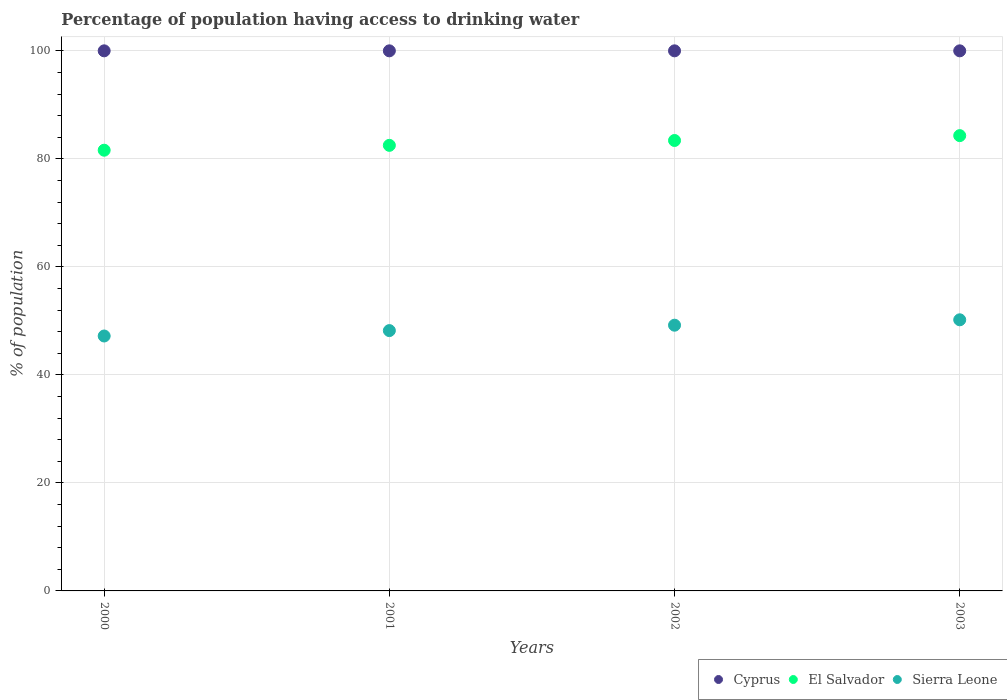What is the percentage of population having access to drinking water in Cyprus in 2001?
Your response must be concise. 100. Across all years, what is the maximum percentage of population having access to drinking water in El Salvador?
Ensure brevity in your answer.  84.3. Across all years, what is the minimum percentage of population having access to drinking water in El Salvador?
Your answer should be compact. 81.6. In which year was the percentage of population having access to drinking water in Sierra Leone minimum?
Give a very brief answer. 2000. What is the total percentage of population having access to drinking water in El Salvador in the graph?
Your answer should be compact. 331.8. What is the difference between the percentage of population having access to drinking water in Sierra Leone in 2002 and that in 2003?
Your answer should be very brief. -1. What is the difference between the percentage of population having access to drinking water in El Salvador in 2002 and the percentage of population having access to drinking water in Sierra Leone in 2003?
Make the answer very short. 33.2. In the year 2000, what is the difference between the percentage of population having access to drinking water in El Salvador and percentage of population having access to drinking water in Sierra Leone?
Give a very brief answer. 34.4. In how many years, is the percentage of population having access to drinking water in El Salvador greater than 60 %?
Keep it short and to the point. 4. Is the percentage of population having access to drinking water in El Salvador in 2000 less than that in 2003?
Provide a short and direct response. Yes. Is the difference between the percentage of population having access to drinking water in El Salvador in 2001 and 2003 greater than the difference between the percentage of population having access to drinking water in Sierra Leone in 2001 and 2003?
Provide a succinct answer. Yes. What is the difference between the highest and the second highest percentage of population having access to drinking water in Sierra Leone?
Your answer should be very brief. 1. What is the difference between the highest and the lowest percentage of population having access to drinking water in El Salvador?
Provide a succinct answer. 2.7. Is it the case that in every year, the sum of the percentage of population having access to drinking water in Sierra Leone and percentage of population having access to drinking water in El Salvador  is greater than the percentage of population having access to drinking water in Cyprus?
Give a very brief answer. Yes. Does the percentage of population having access to drinking water in Sierra Leone monotonically increase over the years?
Your response must be concise. Yes. How many dotlines are there?
Give a very brief answer. 3. How many years are there in the graph?
Keep it short and to the point. 4. What is the difference between two consecutive major ticks on the Y-axis?
Keep it short and to the point. 20. Does the graph contain any zero values?
Offer a terse response. No. Does the graph contain grids?
Your answer should be compact. Yes. Where does the legend appear in the graph?
Your response must be concise. Bottom right. How many legend labels are there?
Provide a succinct answer. 3. How are the legend labels stacked?
Make the answer very short. Horizontal. What is the title of the graph?
Make the answer very short. Percentage of population having access to drinking water. Does "Kosovo" appear as one of the legend labels in the graph?
Provide a short and direct response. No. What is the label or title of the X-axis?
Provide a short and direct response. Years. What is the label or title of the Y-axis?
Provide a short and direct response. % of population. What is the % of population in El Salvador in 2000?
Keep it short and to the point. 81.6. What is the % of population in Sierra Leone in 2000?
Offer a terse response. 47.2. What is the % of population of El Salvador in 2001?
Offer a terse response. 82.5. What is the % of population in Sierra Leone in 2001?
Provide a succinct answer. 48.2. What is the % of population in Cyprus in 2002?
Ensure brevity in your answer.  100. What is the % of population in El Salvador in 2002?
Your answer should be compact. 83.4. What is the % of population of Sierra Leone in 2002?
Your response must be concise. 49.2. What is the % of population of El Salvador in 2003?
Give a very brief answer. 84.3. What is the % of population of Sierra Leone in 2003?
Make the answer very short. 50.2. Across all years, what is the maximum % of population in Cyprus?
Your response must be concise. 100. Across all years, what is the maximum % of population in El Salvador?
Ensure brevity in your answer.  84.3. Across all years, what is the maximum % of population in Sierra Leone?
Offer a very short reply. 50.2. Across all years, what is the minimum % of population in Cyprus?
Offer a terse response. 100. Across all years, what is the minimum % of population of El Salvador?
Make the answer very short. 81.6. Across all years, what is the minimum % of population in Sierra Leone?
Your answer should be compact. 47.2. What is the total % of population of El Salvador in the graph?
Keep it short and to the point. 331.8. What is the total % of population in Sierra Leone in the graph?
Make the answer very short. 194.8. What is the difference between the % of population in Cyprus in 2000 and that in 2001?
Make the answer very short. 0. What is the difference between the % of population in Sierra Leone in 2000 and that in 2002?
Keep it short and to the point. -2. What is the difference between the % of population of Cyprus in 2000 and that in 2003?
Give a very brief answer. 0. What is the difference between the % of population of Sierra Leone in 2001 and that in 2002?
Your answer should be compact. -1. What is the difference between the % of population in Sierra Leone in 2001 and that in 2003?
Give a very brief answer. -2. What is the difference between the % of population in Cyprus in 2002 and that in 2003?
Provide a short and direct response. 0. What is the difference between the % of population of El Salvador in 2002 and that in 2003?
Make the answer very short. -0.9. What is the difference between the % of population in Cyprus in 2000 and the % of population in Sierra Leone in 2001?
Give a very brief answer. 51.8. What is the difference between the % of population of El Salvador in 2000 and the % of population of Sierra Leone in 2001?
Your response must be concise. 33.4. What is the difference between the % of population in Cyprus in 2000 and the % of population in Sierra Leone in 2002?
Your response must be concise. 50.8. What is the difference between the % of population in El Salvador in 2000 and the % of population in Sierra Leone in 2002?
Give a very brief answer. 32.4. What is the difference between the % of population of Cyprus in 2000 and the % of population of El Salvador in 2003?
Provide a short and direct response. 15.7. What is the difference between the % of population of Cyprus in 2000 and the % of population of Sierra Leone in 2003?
Your answer should be compact. 49.8. What is the difference between the % of population in El Salvador in 2000 and the % of population in Sierra Leone in 2003?
Your answer should be compact. 31.4. What is the difference between the % of population in Cyprus in 2001 and the % of population in El Salvador in 2002?
Keep it short and to the point. 16.6. What is the difference between the % of population in Cyprus in 2001 and the % of population in Sierra Leone in 2002?
Your answer should be very brief. 50.8. What is the difference between the % of population in El Salvador in 2001 and the % of population in Sierra Leone in 2002?
Ensure brevity in your answer.  33.3. What is the difference between the % of population in Cyprus in 2001 and the % of population in Sierra Leone in 2003?
Offer a terse response. 49.8. What is the difference between the % of population of El Salvador in 2001 and the % of population of Sierra Leone in 2003?
Your response must be concise. 32.3. What is the difference between the % of population in Cyprus in 2002 and the % of population in Sierra Leone in 2003?
Your answer should be compact. 49.8. What is the difference between the % of population in El Salvador in 2002 and the % of population in Sierra Leone in 2003?
Give a very brief answer. 33.2. What is the average % of population of El Salvador per year?
Your answer should be very brief. 82.95. What is the average % of population in Sierra Leone per year?
Offer a very short reply. 48.7. In the year 2000, what is the difference between the % of population of Cyprus and % of population of Sierra Leone?
Ensure brevity in your answer.  52.8. In the year 2000, what is the difference between the % of population of El Salvador and % of population of Sierra Leone?
Provide a succinct answer. 34.4. In the year 2001, what is the difference between the % of population in Cyprus and % of population in El Salvador?
Your answer should be very brief. 17.5. In the year 2001, what is the difference between the % of population in Cyprus and % of population in Sierra Leone?
Keep it short and to the point. 51.8. In the year 2001, what is the difference between the % of population in El Salvador and % of population in Sierra Leone?
Provide a short and direct response. 34.3. In the year 2002, what is the difference between the % of population in Cyprus and % of population in Sierra Leone?
Offer a very short reply. 50.8. In the year 2002, what is the difference between the % of population of El Salvador and % of population of Sierra Leone?
Your response must be concise. 34.2. In the year 2003, what is the difference between the % of population of Cyprus and % of population of Sierra Leone?
Offer a very short reply. 49.8. In the year 2003, what is the difference between the % of population in El Salvador and % of population in Sierra Leone?
Offer a very short reply. 34.1. What is the ratio of the % of population of Cyprus in 2000 to that in 2001?
Your response must be concise. 1. What is the ratio of the % of population of El Salvador in 2000 to that in 2001?
Keep it short and to the point. 0.99. What is the ratio of the % of population of Sierra Leone in 2000 to that in 2001?
Give a very brief answer. 0.98. What is the ratio of the % of population of El Salvador in 2000 to that in 2002?
Your response must be concise. 0.98. What is the ratio of the % of population of Sierra Leone in 2000 to that in 2002?
Provide a short and direct response. 0.96. What is the ratio of the % of population of Cyprus in 2000 to that in 2003?
Your response must be concise. 1. What is the ratio of the % of population in Sierra Leone in 2000 to that in 2003?
Your answer should be very brief. 0.94. What is the ratio of the % of population in Cyprus in 2001 to that in 2002?
Offer a terse response. 1. What is the ratio of the % of population of El Salvador in 2001 to that in 2002?
Give a very brief answer. 0.99. What is the ratio of the % of population of Sierra Leone in 2001 to that in 2002?
Offer a terse response. 0.98. What is the ratio of the % of population in Cyprus in 2001 to that in 2003?
Offer a terse response. 1. What is the ratio of the % of population in El Salvador in 2001 to that in 2003?
Your answer should be compact. 0.98. What is the ratio of the % of population of Sierra Leone in 2001 to that in 2003?
Keep it short and to the point. 0.96. What is the ratio of the % of population in Cyprus in 2002 to that in 2003?
Ensure brevity in your answer.  1. What is the ratio of the % of population of El Salvador in 2002 to that in 2003?
Offer a terse response. 0.99. What is the ratio of the % of population of Sierra Leone in 2002 to that in 2003?
Ensure brevity in your answer.  0.98. What is the difference between the highest and the second highest % of population in Cyprus?
Ensure brevity in your answer.  0. What is the difference between the highest and the second highest % of population in El Salvador?
Offer a terse response. 0.9. What is the difference between the highest and the second highest % of population in Sierra Leone?
Provide a succinct answer. 1. What is the difference between the highest and the lowest % of population of El Salvador?
Provide a short and direct response. 2.7. What is the difference between the highest and the lowest % of population in Sierra Leone?
Make the answer very short. 3. 